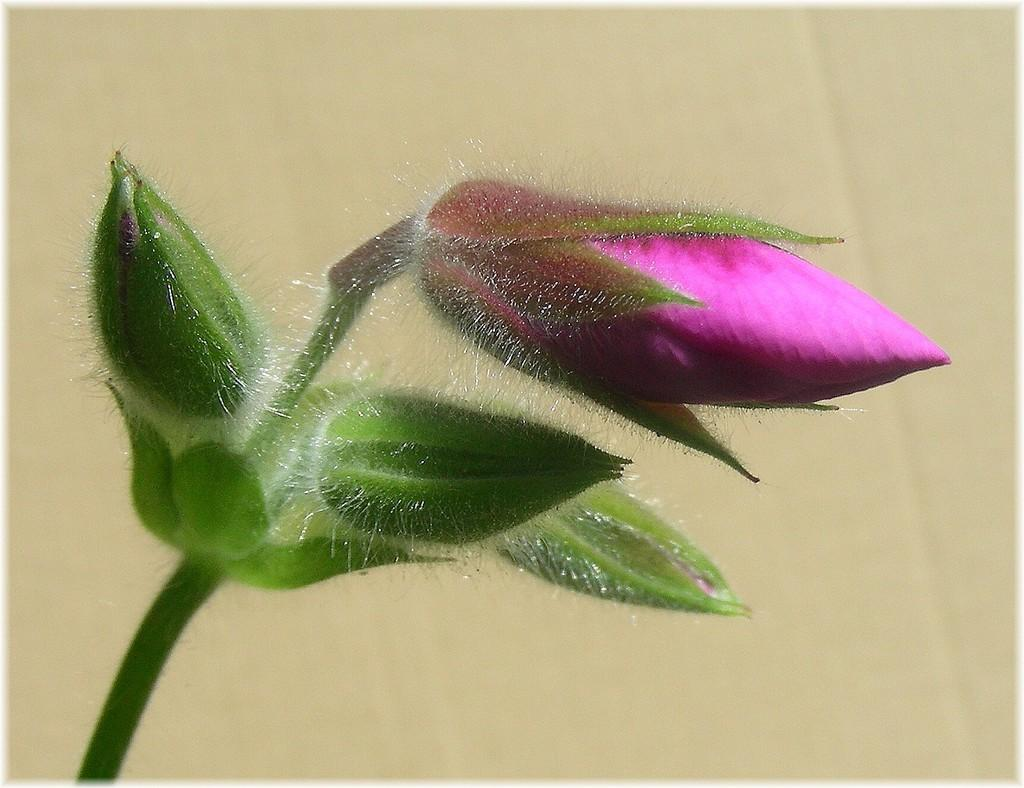What is the main subject of the image? The main subject of the image is a stem with buds and a flower. Can you describe the flower in the image? The flower has buds and is part of the stem in the image. What can be seen in the background of the image? There is a wall visible in the background of the image. What type of reward is being given to the church in the image? There is no church or reward present in the image; it features a stem with buds and a flower, along with a wall in the background. 